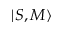Convert formula to latex. <formula><loc_0><loc_0><loc_500><loc_500>| S , M \rangle</formula> 